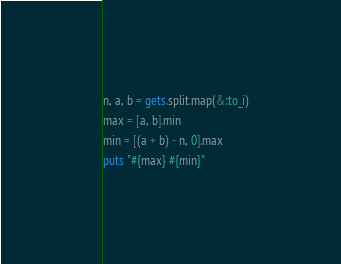<code> <loc_0><loc_0><loc_500><loc_500><_Ruby_>n, a, b = gets.split.map(&:to_i)
max = [a, b].min
min = [(a + b) - n, 0].max
puts "#{max} #{min}"
</code> 